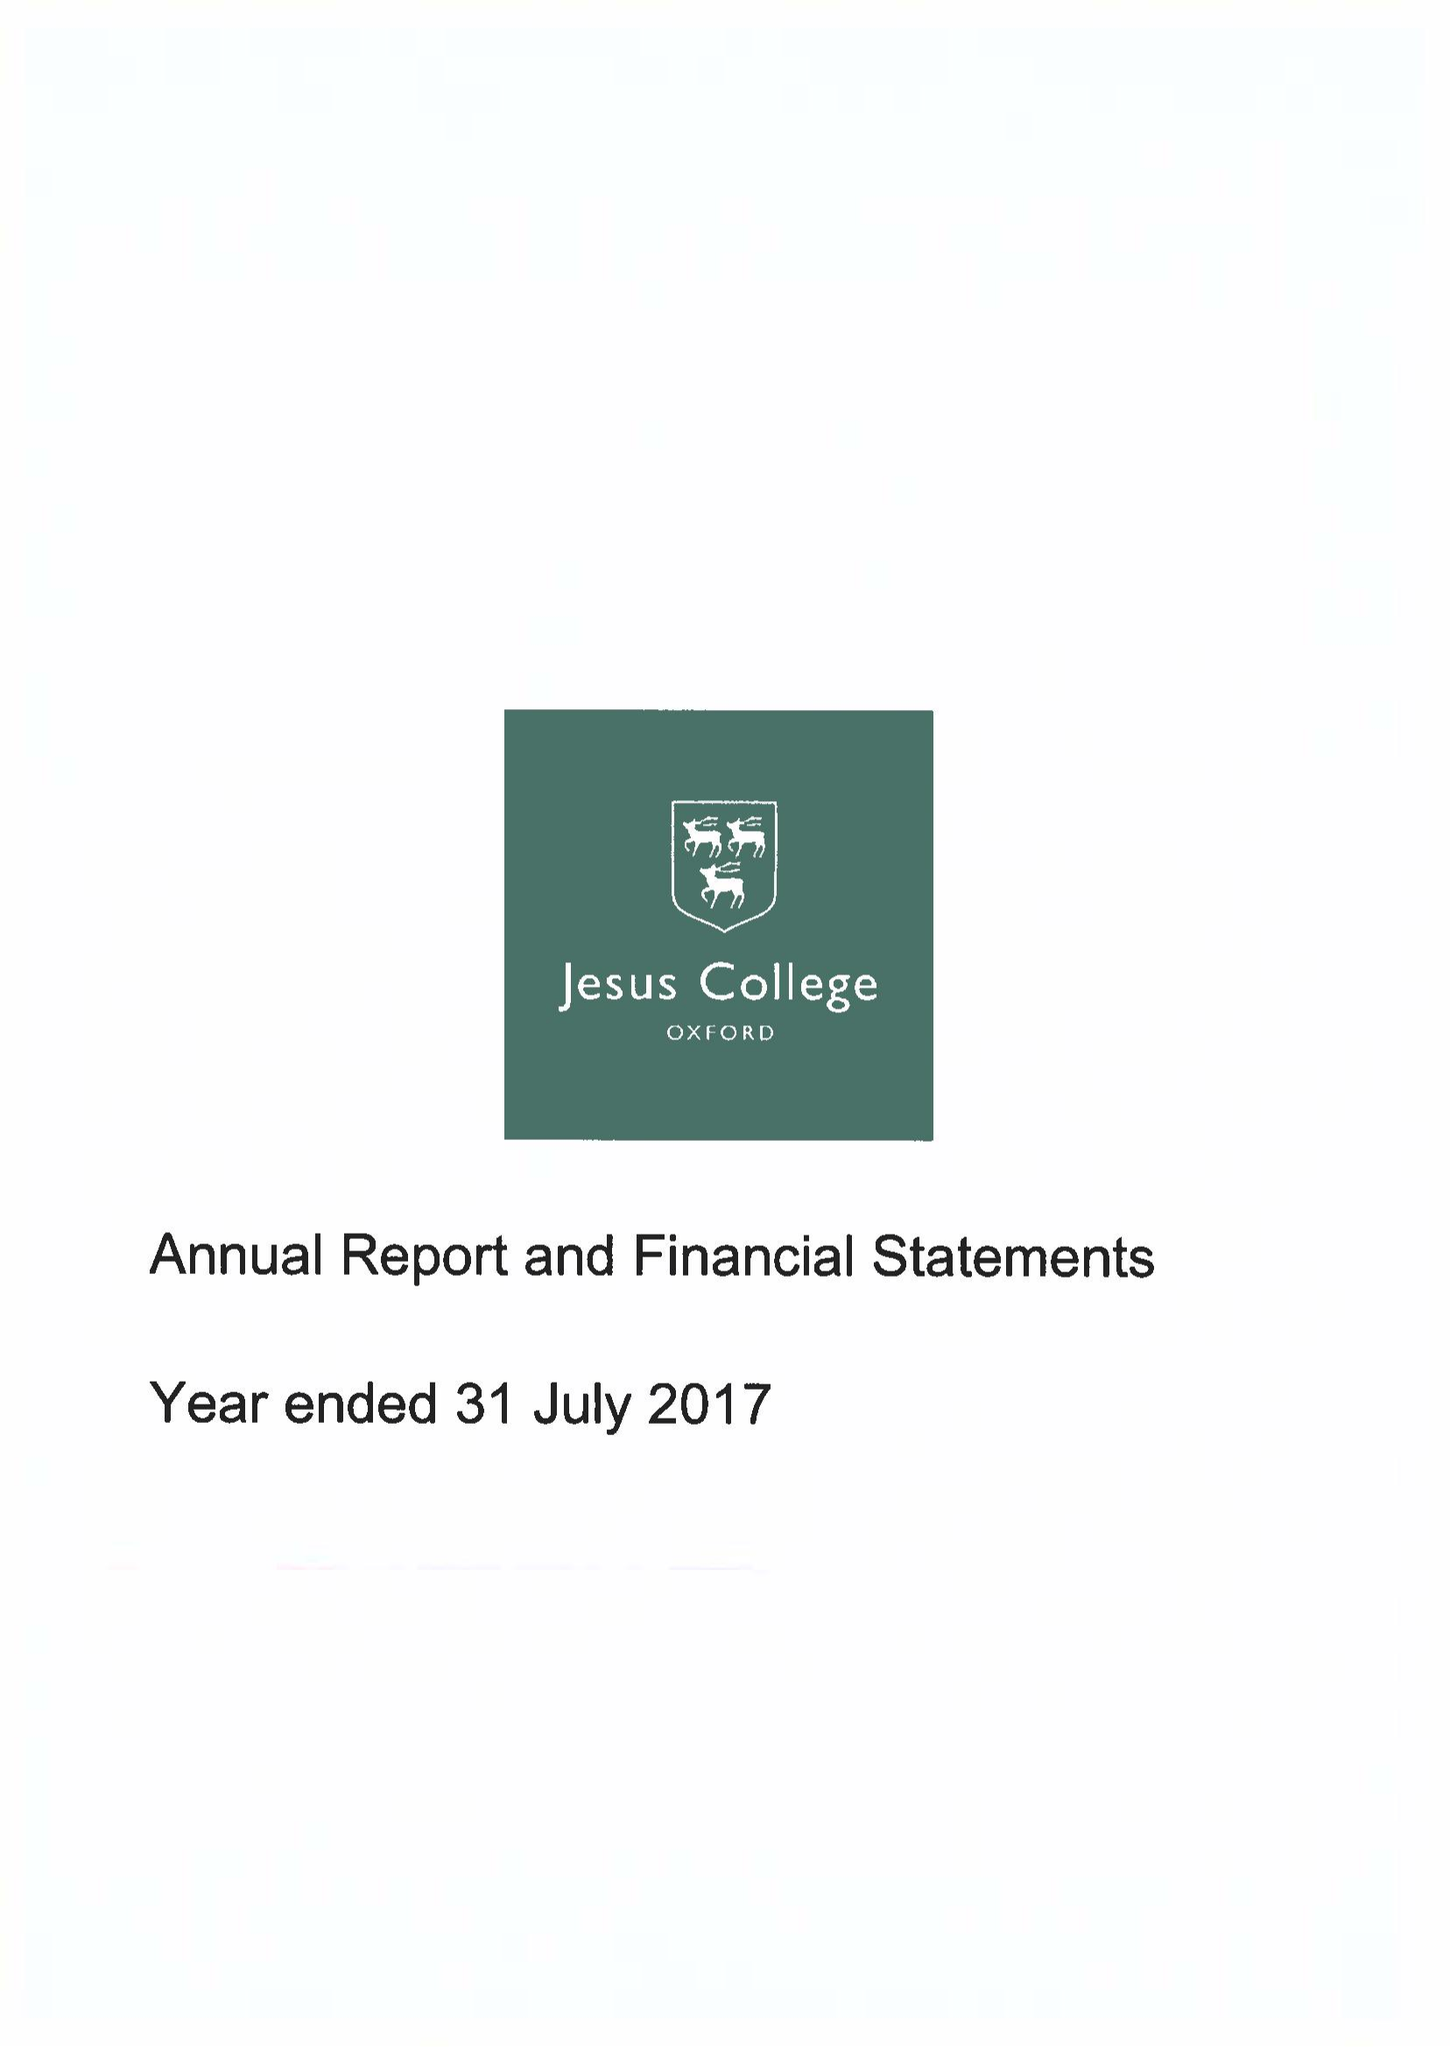What is the value for the report_date?
Answer the question using a single word or phrase. 2017-07-31 